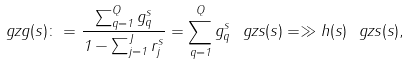Convert formula to latex. <formula><loc_0><loc_0><loc_500><loc_500>\ g z g ( s ) \colon = \frac { \sum _ { q = 1 } ^ { Q } g _ { q } ^ { s } } { 1 - \sum _ { j = 1 } ^ { J } r _ { j } ^ { s } } = \sum _ { q = 1 } ^ { Q } g _ { q } ^ { s } \ g z s ( s ) = \gg h ( s ) \ g z s ( s ) ,</formula> 